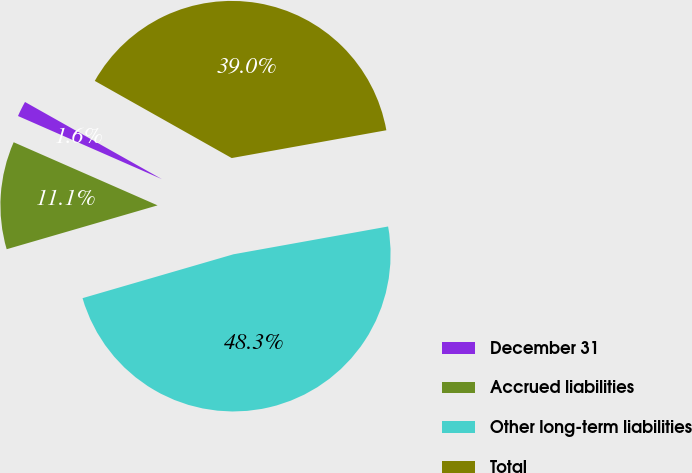<chart> <loc_0><loc_0><loc_500><loc_500><pie_chart><fcel>December 31<fcel>Accrued liabilities<fcel>Other long-term liabilities<fcel>Total<nl><fcel>1.59%<fcel>11.08%<fcel>48.33%<fcel>39.0%<nl></chart> 